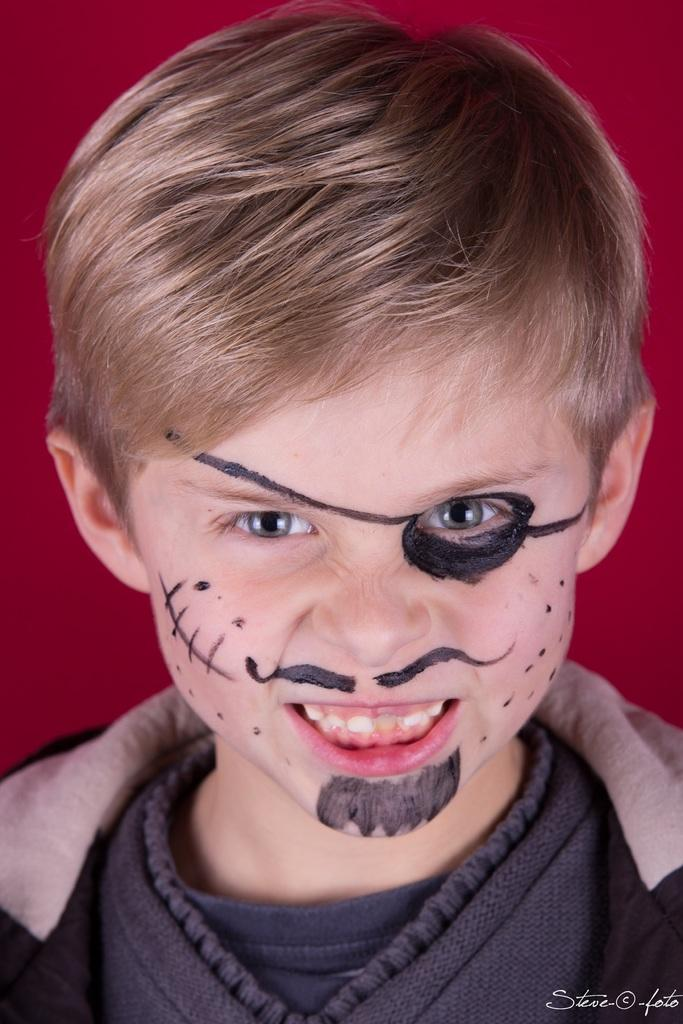Who is the main subject in the image? There is a boy in the image. What is unique about the boy's appearance? The boy has a painting on his face. What emotion is the boy expressing? The boy is smiling. What color dominates the background of the image? The background of the image is red. What type of machine is the boy operating in the image? There is no machine present in the image; it features a boy with a painting on his face and a red background. 